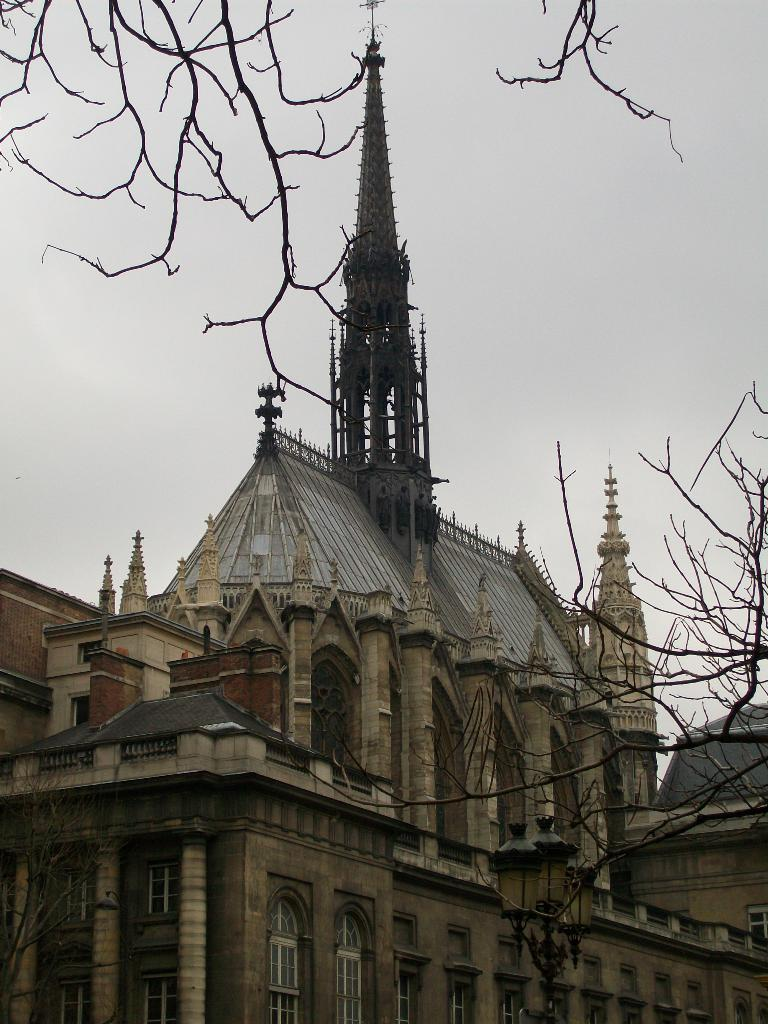What type of structure is present in the image? There is a building in the image. What natural element can be seen in the image? There are branches of a tree in the image. What is visible in the background of the image? The sky is visible in the background of the image. What feature allows for a view of the outside from within the building? There is a window in the image. Who is the manager of the war depicted in the image? There is no war depicted in the image, and therefore no manager is present. What type of furniture can be seen in the image? There is no furniture present in the image. 